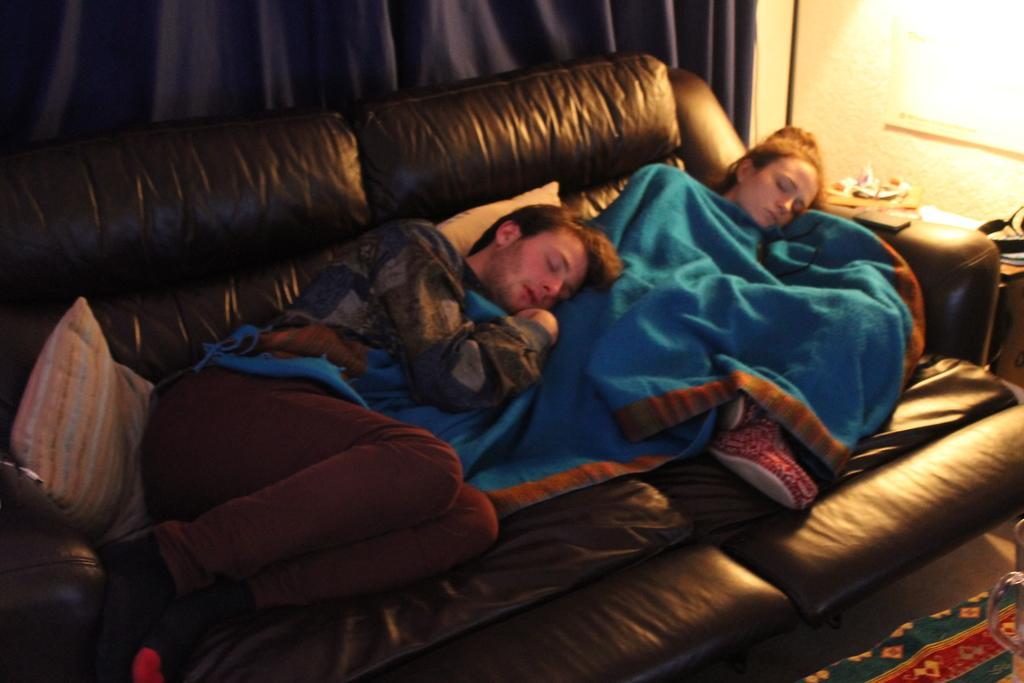Please provide a concise description of this image. In the foreground I can see two persons are sleeping on the sofa, cushion and a blanket. In the background I can see a curtain, table, mobile, light and some objects. This image is taken may be in a room. 